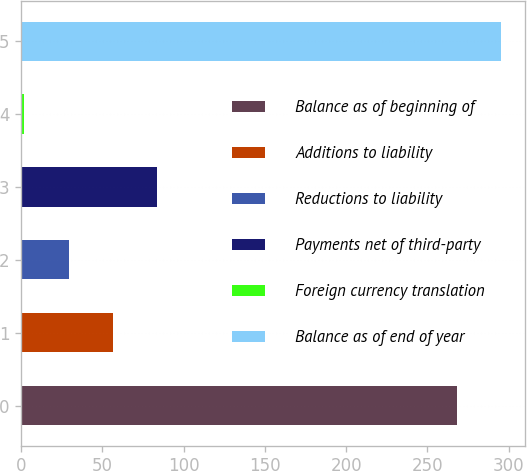Convert chart. <chart><loc_0><loc_0><loc_500><loc_500><bar_chart><fcel>Balance as of beginning of<fcel>Additions to liability<fcel>Reductions to liability<fcel>Payments net of third-party<fcel>Foreign currency translation<fcel>Balance as of end of year<nl><fcel>268<fcel>56.4<fcel>29.2<fcel>83.6<fcel>2<fcel>295.2<nl></chart> 